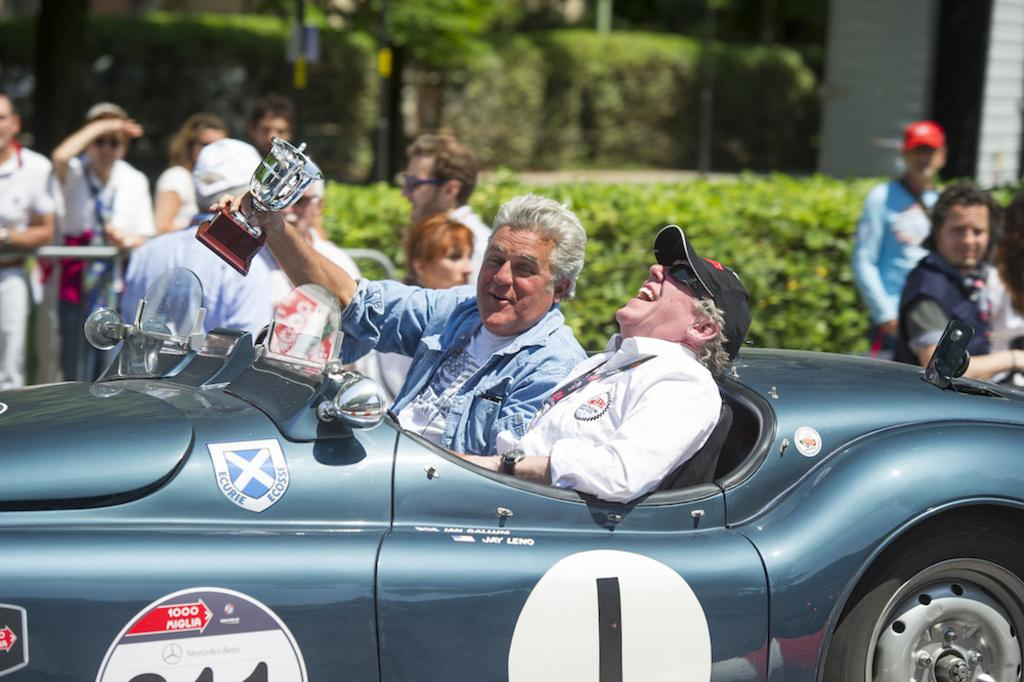What are the people in the image doing? There are persons standing in the image, and two persons are sitting in a vehicle. What can be seen in the background of the image? There are plants and a tree visible in the background. Can you describe any objects being held by the people in the image? Yes, a person is holding a trophy in the image. What type of nose can be seen on the person holding the trophy? There is no nose visible on the person holding the trophy in the image. Can you describe the print on the trophy? The image does not show any print on the trophy; it only shows the trophy being held by a person. 